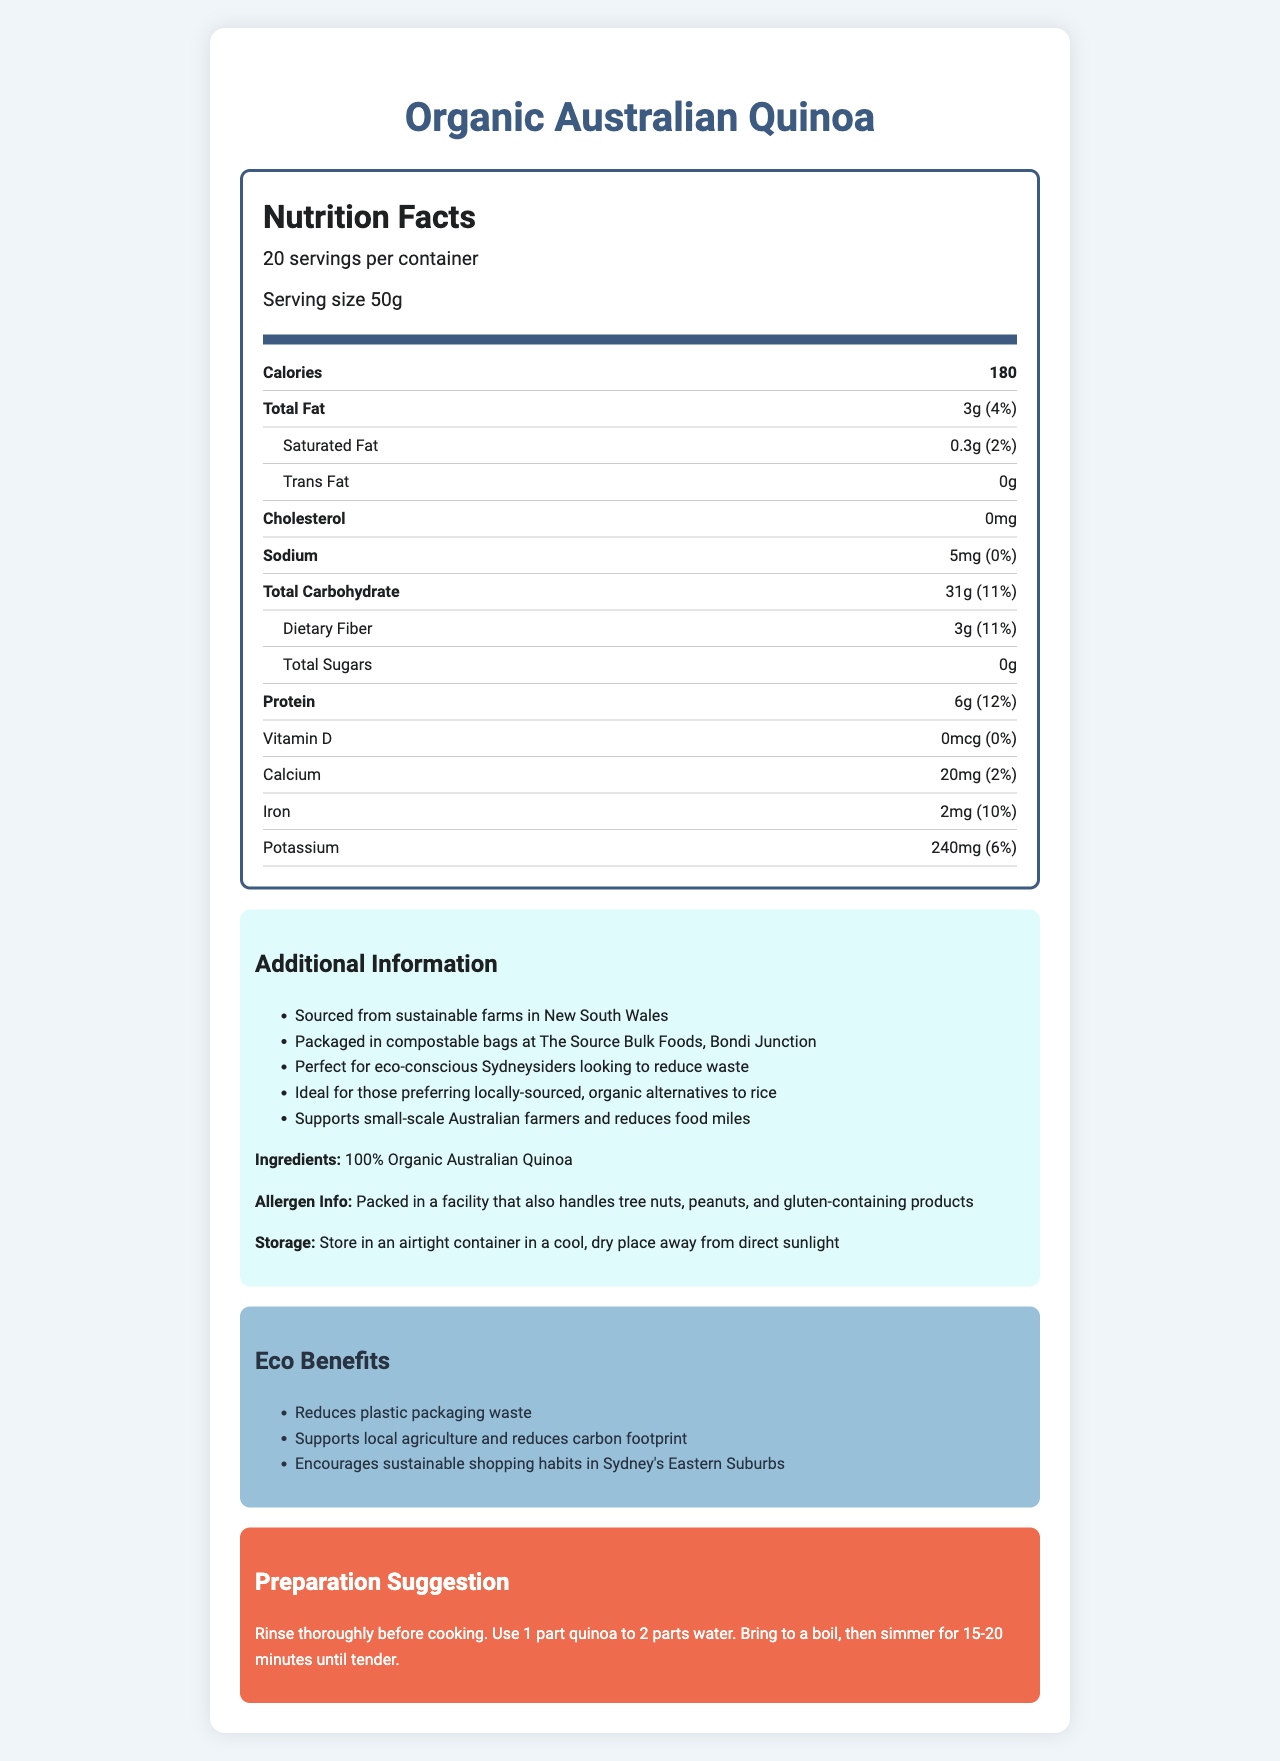what is the serving size? The serving size is listed as "Serving size 50g" in the nutrition label.
Answer: 50g how many calories are in one serving? The nutrition label lists "Calories 180" for one serving.
Answer: 180 how much protein is in one serving? Under the protein section, it states "Protein: 6g".
Answer: 6g what percentage of the daily value is the iron content? The iron content is listed as 2mg, which corresponds to 10% of the daily value.
Answer: 10% what are the ingredients in the product? The ingredients section states "Ingredients: 100% Organic Australian Quinoa".
Answer: 100% Organic Australian Quinoa where is the quinoa sourced from? Under the additional information, it states "Sourced from sustainable farms in New South Wales".
Answer: Sustainable farms in New South Wales what is the preparation suggestion for this quinoa? The preparation section provides detailed instructions: "Rinse thoroughly before cooking. Use 1 part quinoa to 2 parts water. Bring to a boil, then simmer for 15-20 minutes until tender."
Answer: Rinse thoroughly before cooking. Use 1 part quinoa to 2 parts water. Bring to a boil, then simmer for 15-20 minutes until tender. what is the main purpose of the eco benefits section? The eco benefits section lists how the product reduces waste, supports local agriculture, and encourages sustainable shopping habits.
Answer: To highlight the environmental advantages of the product how much calcium is in one serving, and what percentage of the daily value does this represent? The nutrition label lists "Calcium: 20mg (2%)".
Answer: 20mg, 2% what is the amount of dietary fiber per serving? The dietary fiber section specifies "Dietary Fiber: 3g".
Answer: 3g what are the storage instructions for this product? The storage instructions section states: "Store in an airtight container in a cool, dry place away from direct sunlight."
Answer: Store in an airtight container in a cool, dry place away from direct sunlight how does this product support local agriculture? A. By using imported quinoa B. By sourcing from local farms C. By providing recipes The additional information clearly states "Supports small-scale Australian farmers" which indicates sourcing from local farms.
Answer: B what is the total fat content in one serving? A. 1g B. 2g C. 3g D. 4g The total fat content is listed as "Total Fat: 3g".
Answer: C is there any cholesterol in this product? The nutrition label states "Cholesterol: 0mg", indicating no cholesterol.
Answer: No does this product contain any added sugars? The nutrition label states "Total Sugars: 0g", indicating that it contains no sugars.
Answer: No is this product suitable for those looking to reduce food miles? The additional information states that this product "reduces food miles", making it suitable for those with such goals.
Answer: Yes summarize the main idea of the document. This document comprehensively covers nutritional facts as well as environmental and practical aspects of the product "Organic Australian Quinoa".
Answer: The document provides detailed nutritional information about Organic Australian Quinoa, including serving size, calories, and macronutrient content. It also highlights the eco-friendly packaging, sourcing from sustainable farms, and storage instructions. Additionally, it offers preparation suggestions and emphasizes the environmental benefits of supporting local agriculture and reducing waste. what is the exact carbon footprint reduction from this product? The document mentions that the product "reduces carbon footprint", but it does not provide specific data or figures to quantify the reduction.
Answer: Not enough information 